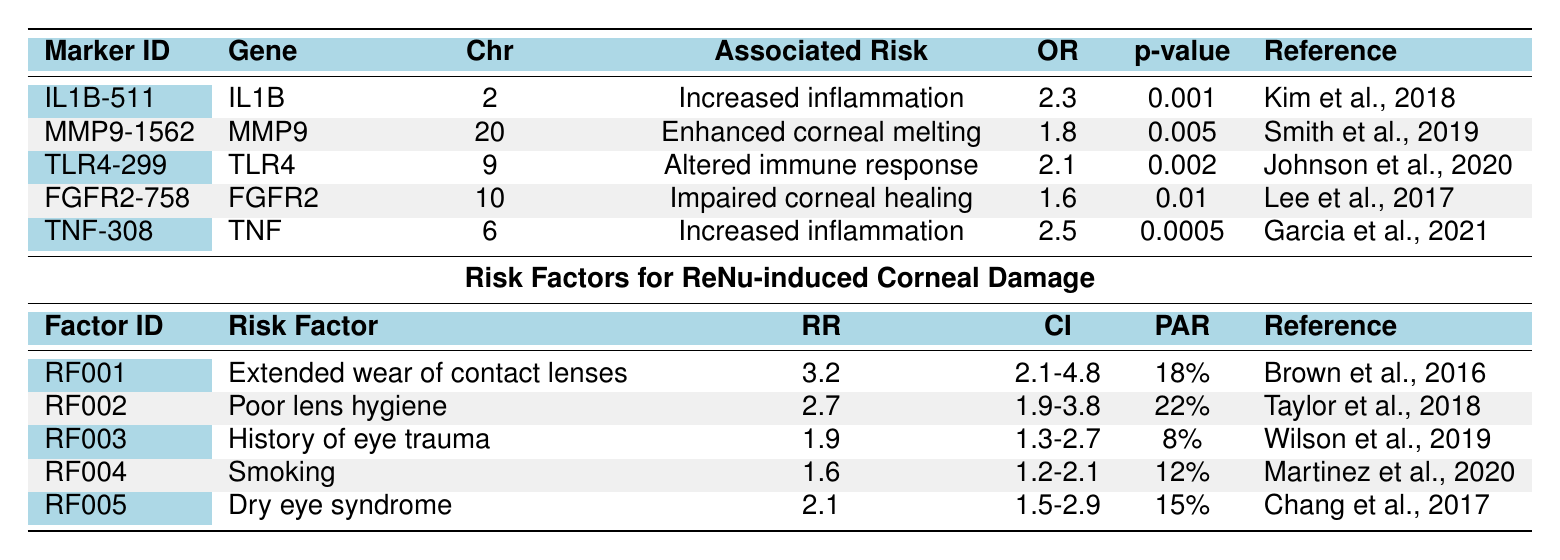What is the odds ratio for the IL1B marker associated with corneal damage from ReNu? The table shows that the odds ratio (OR) for the IL1B marker (marker ID: IL1B-511) is 2.3.
Answer: 2.3 What risk factor has the highest relative risk associated with ReNu-induced corneal damage? By reviewing the relative risks (RR) in the table, the highest RR is 3.2 for the risk factor "Extended wear of contact lenses."
Answer: Extended wear of contact lenses Is the p-value for the TNF gene statistically significant? A p-value less than 0.05 indicates statistical significance. The p-value for the TNF gene is 0.0005, which is less than 0.05, thus it is statistically significant.
Answer: Yes Which genetic marker is associated with impaired corneal healing? The marker associated with impaired corneal healing is FGFR2 (marker ID: FGFR2-758).
Answer: FGFR2 How many genetic markers are listed in the table that are associated with increased inflammation? Two markers are associated with increased inflammation (IL1B-511 and TNF-308).
Answer: 2 What is the confidence interval for the risk factor related to poor lens hygiene? The table states that the confidence interval (CI) for the risk factor "Poor lens hygiene" is 1.9-3.8.
Answer: 1.9-3.8 Which chromosome is the gene TLR4 located on, and what is its associated risk? According to the table, TLR4 is located on chromosome 9 and is associated with "Altered immune response."
Answer: Chromosome 9; Altered immune response What is the combined population attributable risk for smoking and dry eye syndrome? The population attributable risk (PAR) for smoking is 12% and for dry eye syndrome is 15%. Their combined risk is 12% + 15% = 27%.
Answer: 27% Is there a significant difference in odds ratios between MMP9 and TLR4? The odds ratio for MMP9 is 1.8 and for TLR4 is 2.1. Since 2.1 is greater than 1.8, there is a significant difference favoring TLR4.
Answer: Yes What is the average relative risk of the risk factors listed in the table? The relative risks are 3.2, 2.7, 1.9, 1.6, and 2.1. Their sum is 3.2 + 2.7 + 1.9 + 1.6 + 2.1 = 11.5. Dividing by 5 gives an average relative risk of 11.5 / 5 = 2.3.
Answer: 2.3 